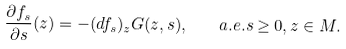<formula> <loc_0><loc_0><loc_500><loc_500>\frac { \partial f _ { s } } { \partial s } ( z ) = - ( d f _ { s } ) _ { z } G ( z , s ) , \quad a . e . s \geq 0 , z \in M .</formula> 